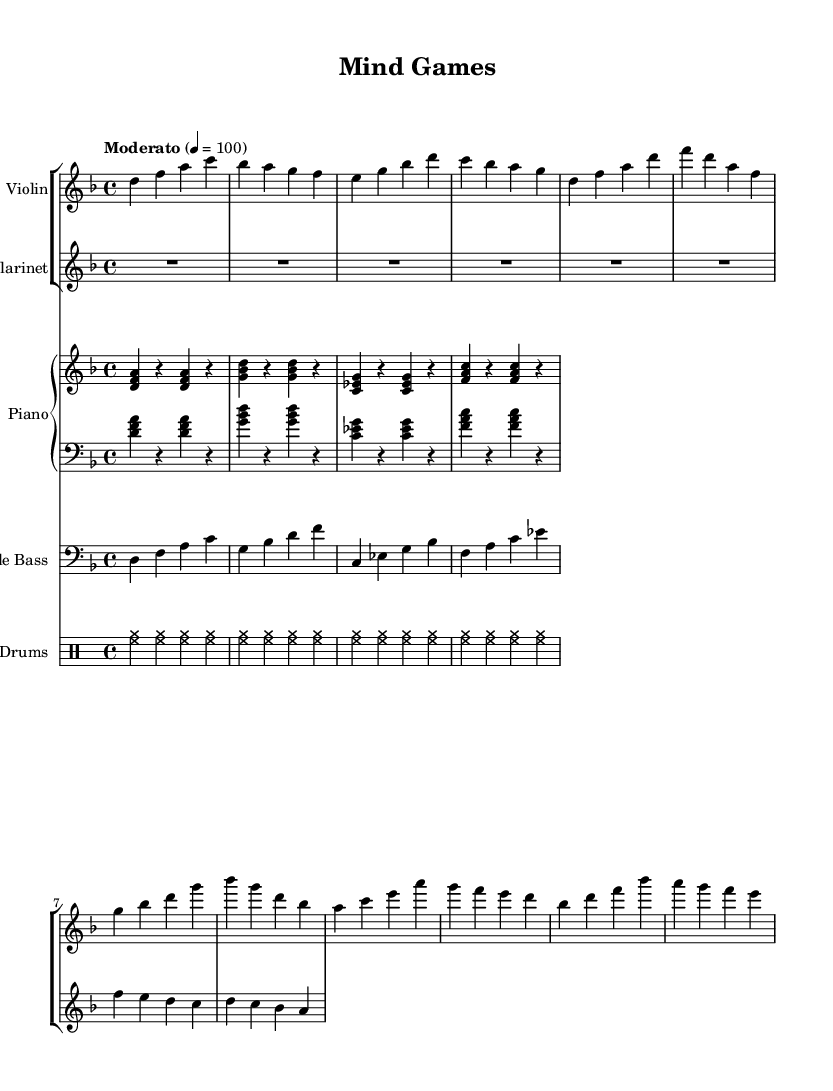What is the key signature of this music? The key signature is D minor, as indicated by one flat (B flat) shown at the beginning of the staff.
Answer: D minor What is the time signature of this music? The time signature is 4/4, which means there are four beats in each measure and a quarter note receives one beat, as indicated at the beginning of the score.
Answer: 4/4 What is the tempo marking of the piece? The tempo marking is Moderato, which indicates a moderately paced tempo, as stated at the beginning of the score.
Answer: Moderato How many measures are in Theme A? Theme A consists of four measures, as seen in the initial four bars designated for it in the sheet music.
Answer: Four What instruments are playing during Theme B? During Theme B, the violin and clarinet are both playing, as denoted by their respective staves being active during that section.
Answer: Violin and Clarinet What type of bass line is present in this piece? The bass line is a walking bass line, characterized by a smooth, connected melodic line played in a rhythmic style typical of jazz, as indicated by the patterns shown in the bass part.
Answer: Walking bass line What rhythmic pattern is used by the drums? The drums use a basic jazz ride pattern, which is evident from the repetitive hihat notation throughout the measures indicated.
Answer: Jazz ride pattern 